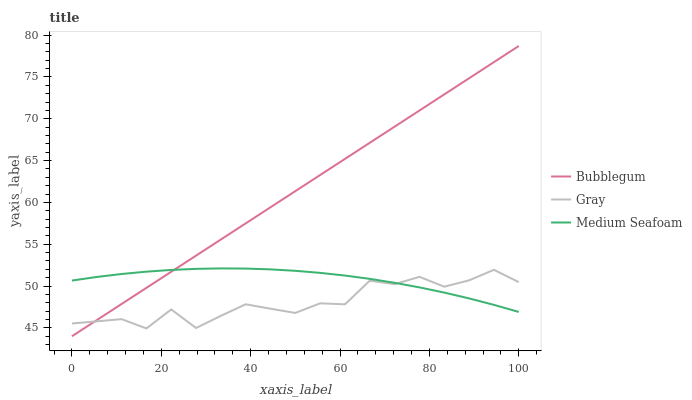Does Medium Seafoam have the minimum area under the curve?
Answer yes or no. No. Does Medium Seafoam have the maximum area under the curve?
Answer yes or no. No. Is Medium Seafoam the smoothest?
Answer yes or no. No. Is Medium Seafoam the roughest?
Answer yes or no. No. Does Medium Seafoam have the lowest value?
Answer yes or no. No. Does Medium Seafoam have the highest value?
Answer yes or no. No. 